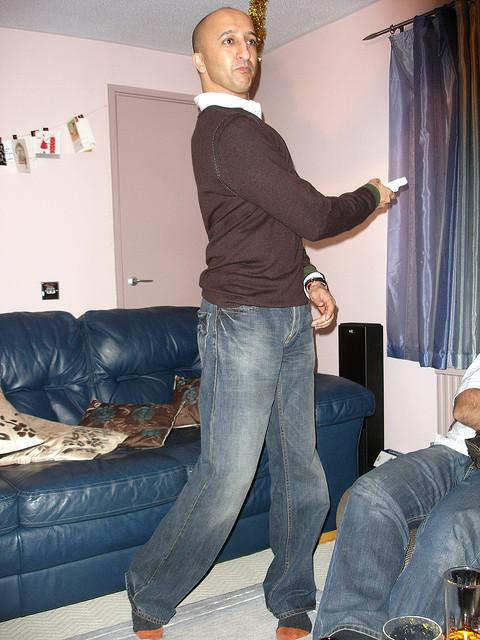What process is used to create the pillow fabric? Please explain your reasoning. embroidery. The pillow fabric has stitches on it. 